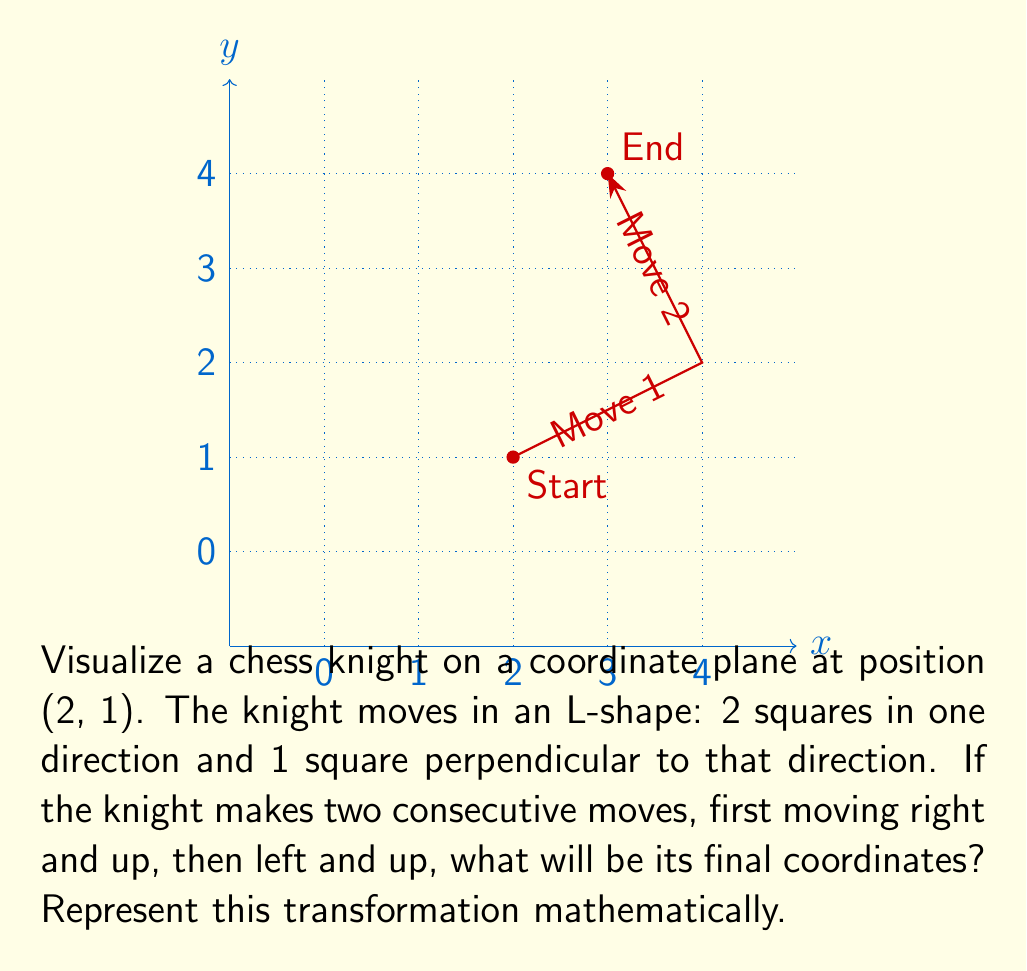Give your solution to this math problem. To solve this problem, we need to break it down into steps and represent each move as a vector transformation:

1) Initial position: (2, 1)

2) First move (right and up):
   - Right 2 squares: +2 in x-direction
   - Up 1 square: +1 in y-direction
   - Vector representation: $\vec{v}_1 = (2, 1)$

3) Second move (left and up):
   - Left 1 square: -1 in x-direction
   - Up 2 squares: +2 in y-direction
   - Vector representation: $\vec{v}_2 = (-1, 2)$

4) To find the final position, we add these vectors to the initial position:
   $$(2, 1) + \vec{v}_1 + \vec{v}_2 = (2, 1) + (2, 1) + (-1, 2)$$

5) Calculating:
   $$(2+2-1, 1+1+2) = (3, 4)$$

Therefore, the knight's final position after these two moves is (3, 4).

The mathematical representation of this transformation can be written as:
$$T(x, y) = (x, y) + (2, 1) + (-1, 2) = (x+1, y+3)$$

Where $T$ is the transformation function applied to the initial coordinates (x, y).
Answer: (3, 4) 